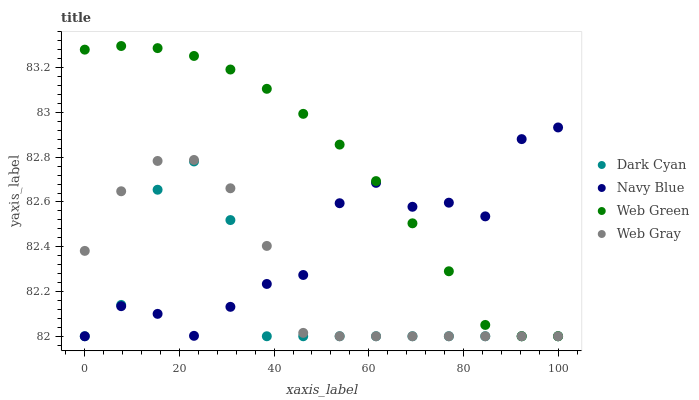Does Dark Cyan have the minimum area under the curve?
Answer yes or no. Yes. Does Web Green have the maximum area under the curve?
Answer yes or no. Yes. Does Navy Blue have the minimum area under the curve?
Answer yes or no. No. Does Navy Blue have the maximum area under the curve?
Answer yes or no. No. Is Web Green the smoothest?
Answer yes or no. Yes. Is Navy Blue the roughest?
Answer yes or no. Yes. Is Web Gray the smoothest?
Answer yes or no. No. Is Web Gray the roughest?
Answer yes or no. No. Does Dark Cyan have the lowest value?
Answer yes or no. Yes. Does Web Green have the highest value?
Answer yes or no. Yes. Does Navy Blue have the highest value?
Answer yes or no. No. Does Dark Cyan intersect Navy Blue?
Answer yes or no. Yes. Is Dark Cyan less than Navy Blue?
Answer yes or no. No. Is Dark Cyan greater than Navy Blue?
Answer yes or no. No. 